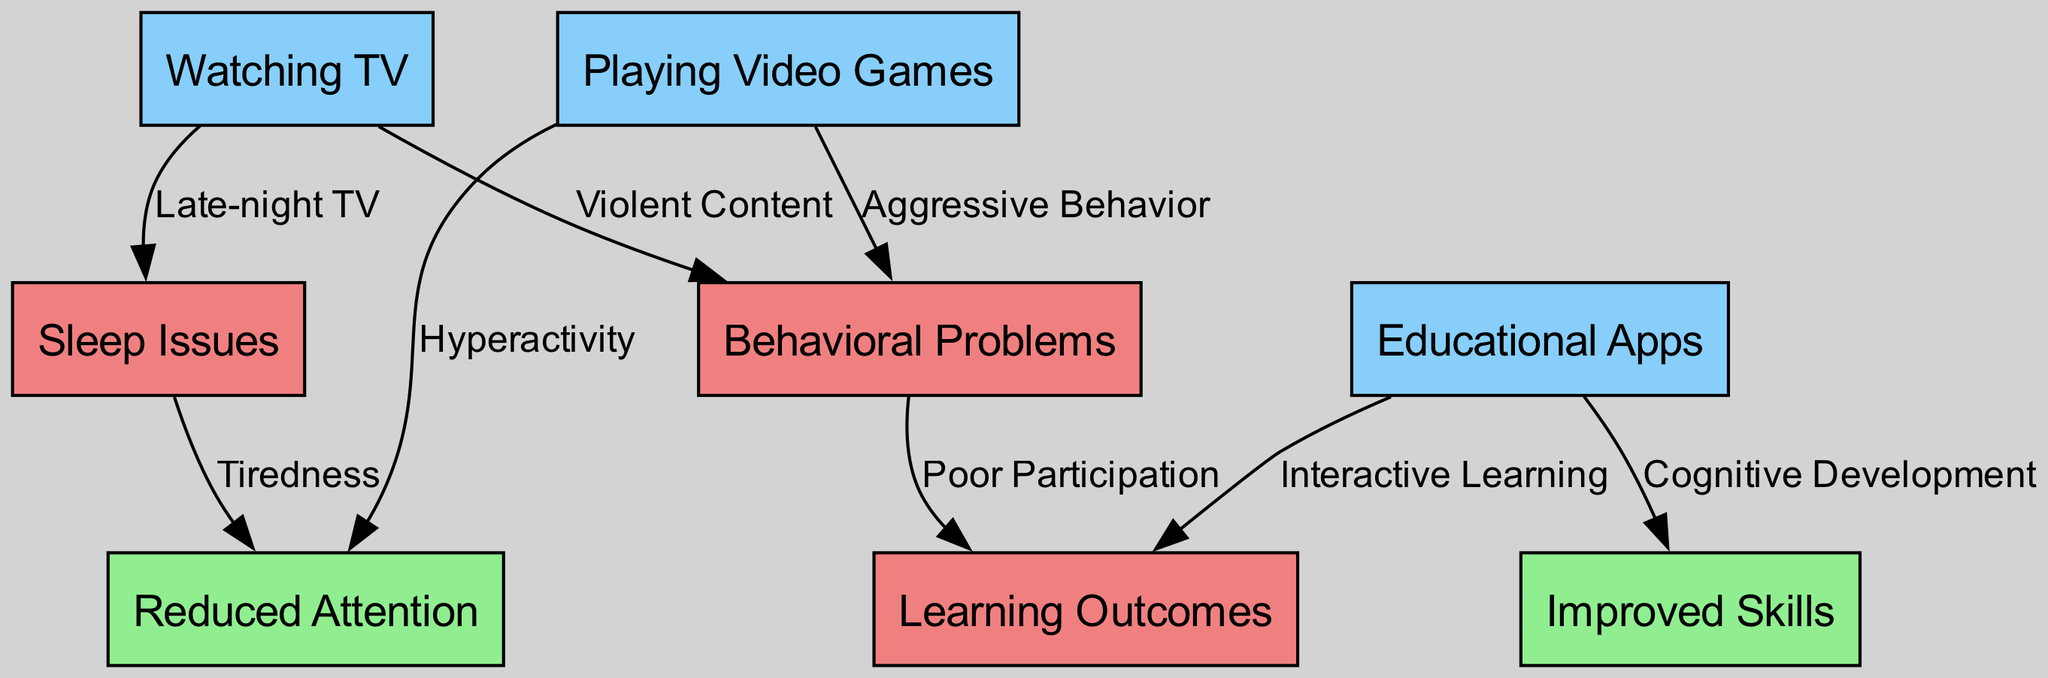What are the three screen activities shown in the diagram? The diagram contains three main screen activities: watching TV, playing video games, and educational apps. These activities are represented as nodes at the top of the flowchart.
Answer: Watching TV, Playing Video Games, Educational Apps How many edges are there connecting the nodes related to sleep issues? There are three edges connected to sleep issues: one from watching TV (Late-night TV), and one from behavioral problems (Tiredness). This can be found by counting the directed lines leading to the sleep issues node.
Answer: 3 What effect does playing video games have on behavior? Playing video games can lead to behavioral problems, specifically aggressive behavior. This is indicated by a directed edge from the playing video games node to the behavioral problems node.
Answer: Aggressive Behavior What is the relationship between sleep issues and reduced attention? Sleep issues lead to reduced attention, as indicated by a directed edge labeled "Tiredness" from the sleep issues node to the reduced attention node. This shows a causal link where sleep problems can impact attention spans.
Answer: Tiredness What educational benefit is associated with educational apps? Educational apps are linked to improved learning outcomes through interactive learning and cognitive development. There are two edges leading from educational apps to two nodes that represent these benefits, showing a positive effect on learning.
Answer: Improved Skills, Learning Outcomes Which screen activity is most closely related to sleep issues? Watching TV is most closely related to sleep issues, as indicated by a directed edge labeled "Late-night TV," which suggests that watching TV late can impact sleep negatively.
Answer: Late-night TV 